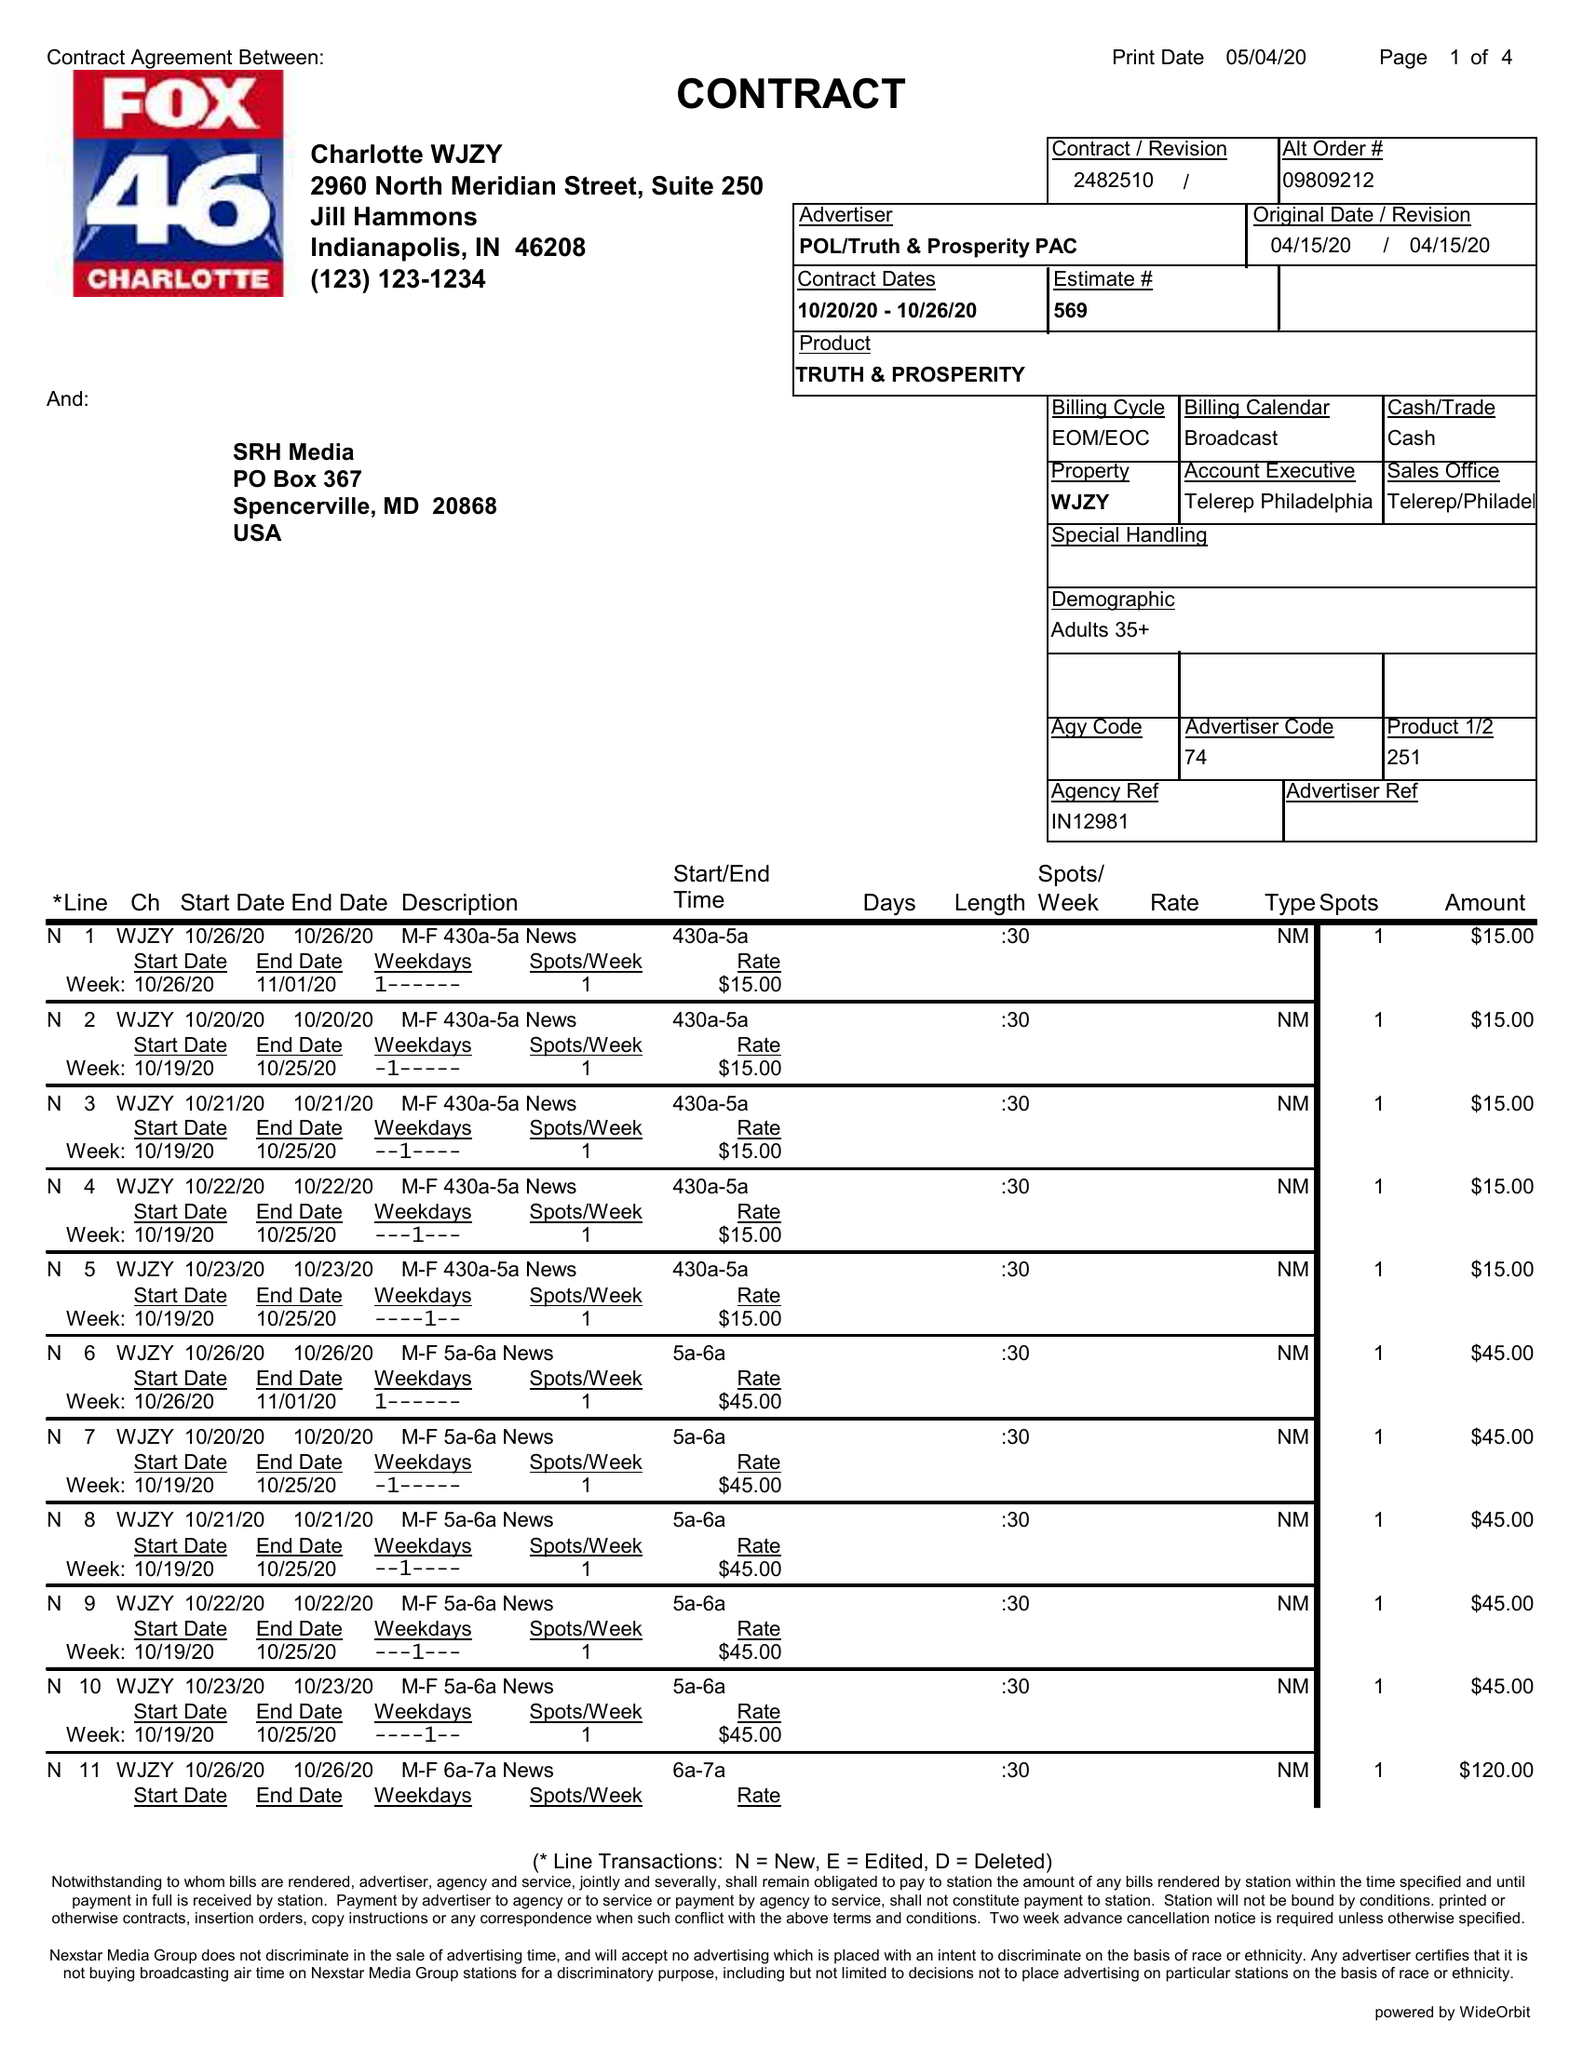What is the value for the contract_num?
Answer the question using a single word or phrase. 2482510 